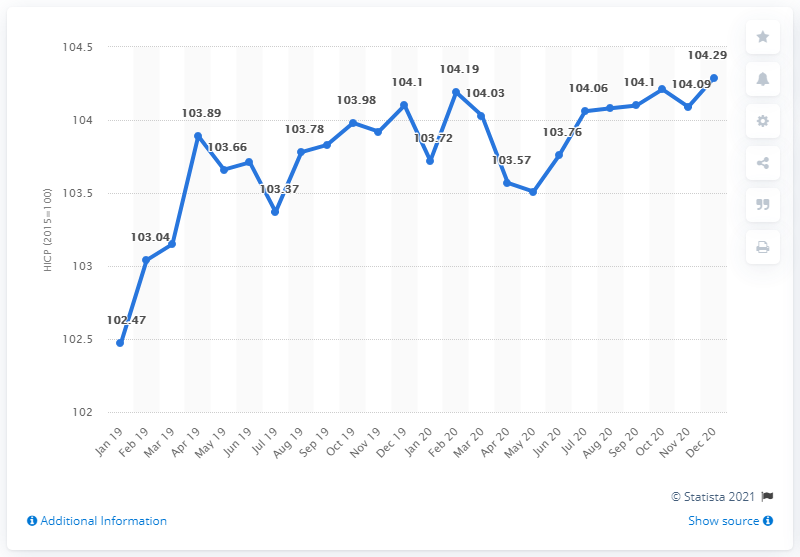Mention a couple of crucial points in this snapshot. In February 2020, the HICP reached a figure point of 104.19. 